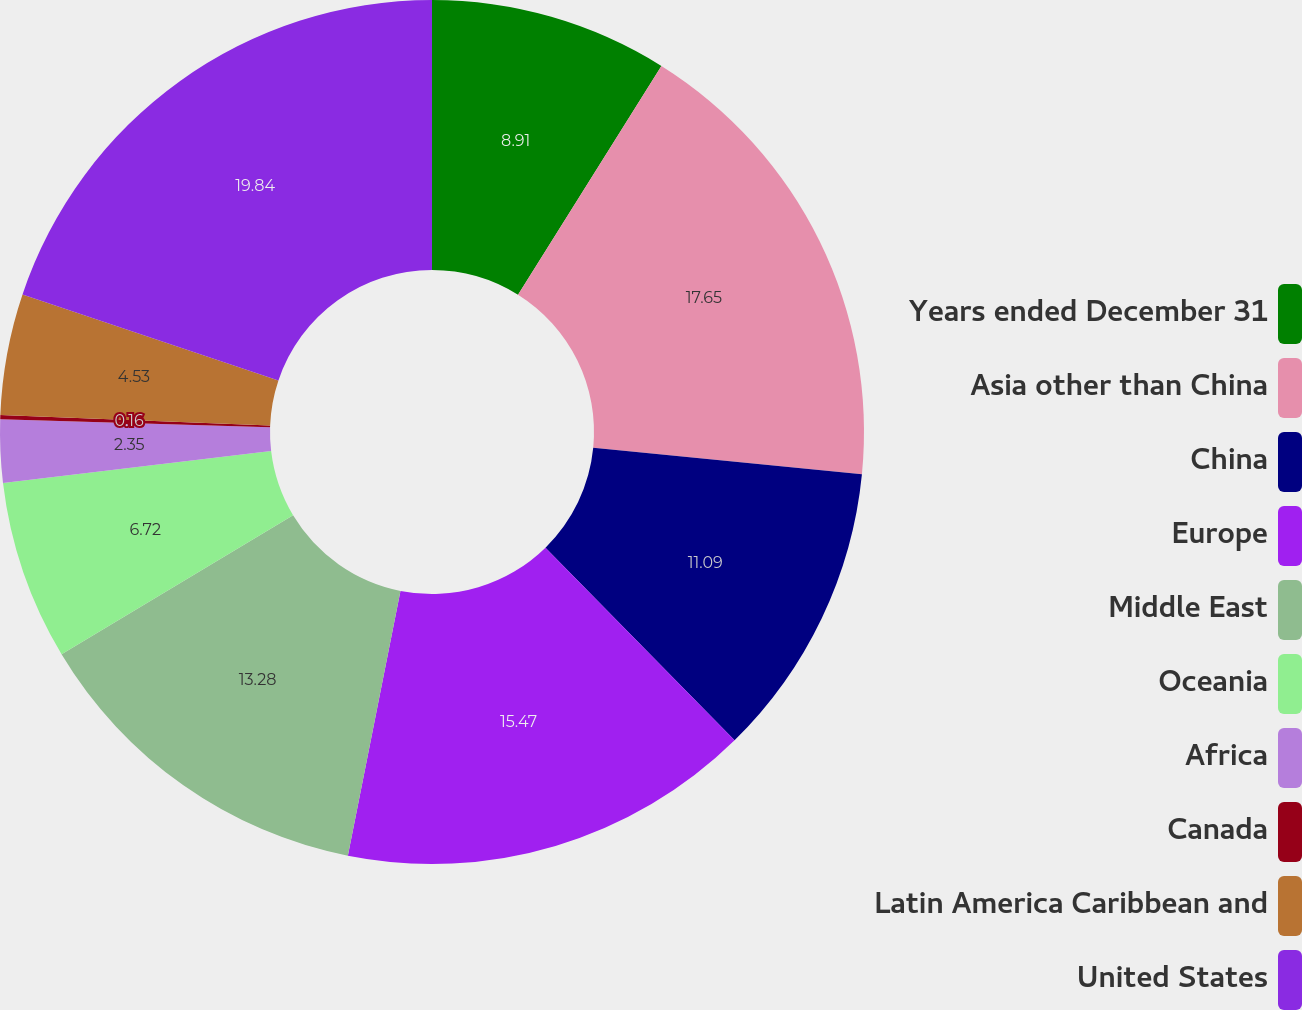Convert chart. <chart><loc_0><loc_0><loc_500><loc_500><pie_chart><fcel>Years ended December 31<fcel>Asia other than China<fcel>China<fcel>Europe<fcel>Middle East<fcel>Oceania<fcel>Africa<fcel>Canada<fcel>Latin America Caribbean and<fcel>United States<nl><fcel>8.91%<fcel>17.65%<fcel>11.09%<fcel>15.47%<fcel>13.28%<fcel>6.72%<fcel>2.35%<fcel>0.16%<fcel>4.53%<fcel>19.84%<nl></chart> 